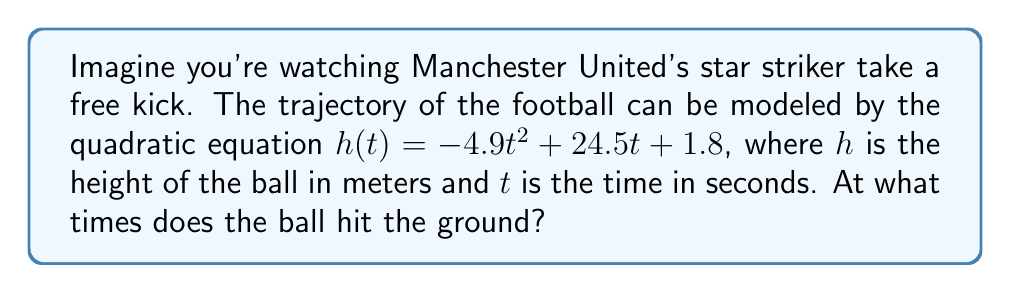Show me your answer to this math problem. To find when the ball hits the ground, we need to solve the equation $h(t) = 0$. This means we're looking for the roots of the quadratic equation:

$$-4.9t^2 + 24.5t + 1.8 = 0$$

Let's solve this step-by-step:

1) First, we'll use the quadratic formula: $t = \frac{-b \pm \sqrt{b^2 - 4ac}}{2a}$

   Where $a = -4.9$, $b = 24.5$, and $c = 1.8$

2) Substituting these values:

   $t = \frac{-24.5 \pm \sqrt{24.5^2 - 4(-4.9)(1.8)}}{2(-4.9)}$

3) Simplify under the square root:

   $t = \frac{-24.5 \pm \sqrt{600.25 + 35.28}}{-9.8}$
   
   $t = \frac{-24.5 \pm \sqrt{635.53}}{-9.8}$

4) Calculate the square root:

   $t = \frac{-24.5 \pm 25.21}{-9.8}$

5) This gives us two solutions:

   $t_1 = \frac{-24.5 + 25.21}{-9.8} \approx 0.07$ seconds
   
   $t_2 = \frac{-24.5 - 25.21}{-9.8} \approx 5.07$ seconds

The ball hits the ground at approximately 0.07 seconds (almost immediately after being kicked) and again at 5.07 seconds.
Answer: $t \approx 0.07$ s and $t \approx 5.07$ s 